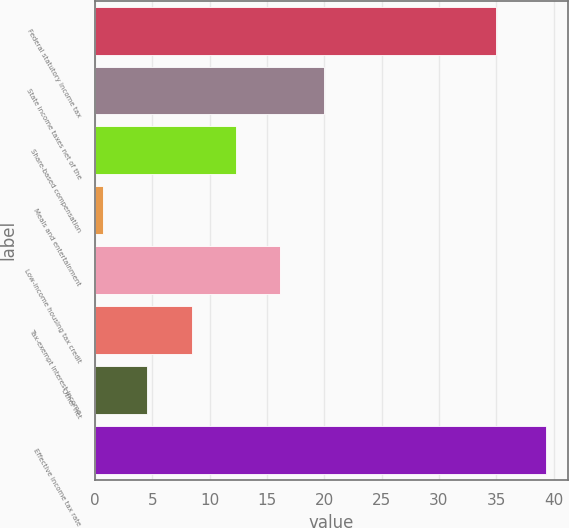Convert chart to OTSL. <chart><loc_0><loc_0><loc_500><loc_500><bar_chart><fcel>Federal statutory income tax<fcel>State income taxes net of the<fcel>Share-based compensation<fcel>Meals and entertainment<fcel>Low-income housing tax credit<fcel>Tax-exempt interest income<fcel>Other net<fcel>Effective income tax rate<nl><fcel>35<fcel>20<fcel>12.28<fcel>0.7<fcel>16.14<fcel>8.42<fcel>4.56<fcel>39.3<nl></chart> 